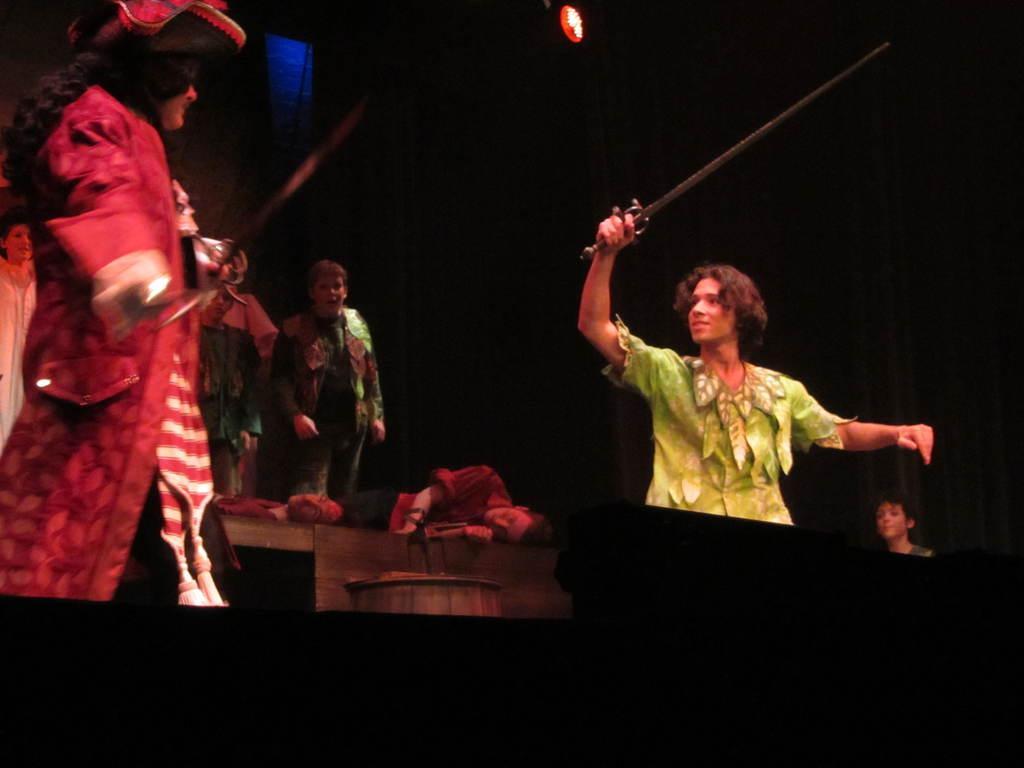In one or two sentences, can you explain what this image depicts? In this image we can see a group of people on the stage. In that some are lying on the floor. We can also see a wooden barrel and a light. In the foreground we can see two people standing holding the swords. 